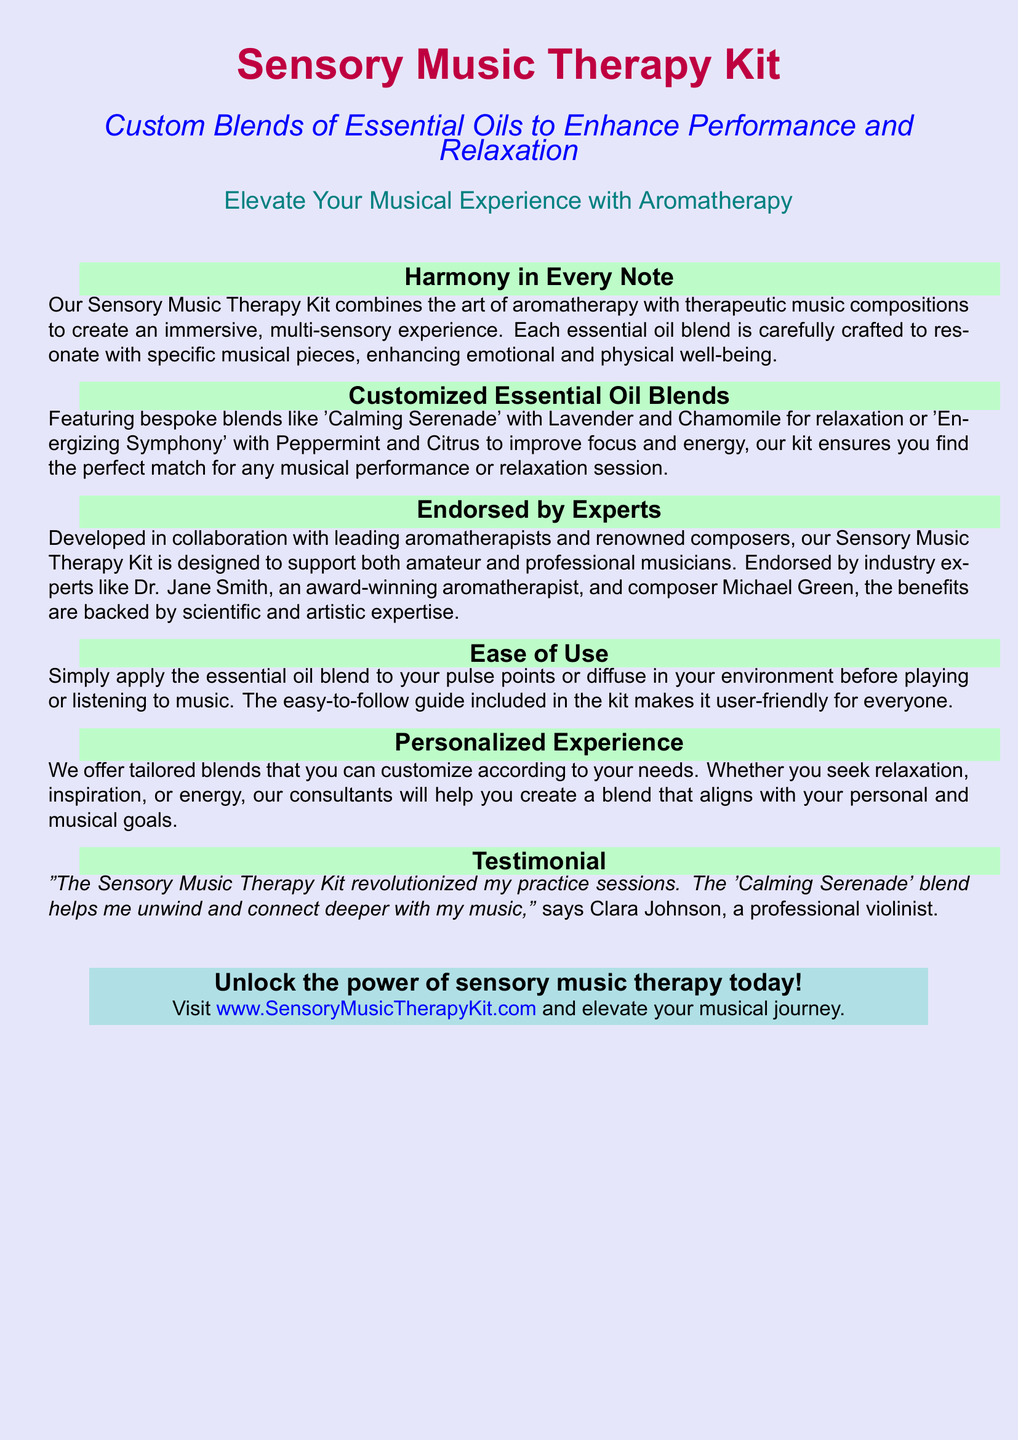What is the name of the product? The product is named in the document as the "Sensory Music Therapy Kit."
Answer: Sensory Music Therapy Kit What are the two essential oils in the 'Calming Serenade' blend? The document specifies that 'Calming Serenade' contains Lavender and Chamomile.
Answer: Lavender and Chamomile Who endorsed the Sensory Music Therapy Kit? The document mentions endorsements from experts like Dr. Jane Smith and composer Michael Green.
Answer: Dr. Jane Smith and Michael Green What is the purpose of the 'Energizing Symphony' blend? The 'Energizing Symphony' blend is designed to improve focus and energy.
Answer: Improve focus and energy How can users apply the essential oil blends? Users can apply the blends to their pulse points or diffuse them in their environment, as per the document.
Answer: Pulse points or diffuse What should users visit to unlock the power of sensory music therapy? The document prompts users to visit a specific website to access the Sensory Music Therapy Kit.
Answer: www.SensoryMusicTherapyKit.com Who is Clara Johnson? Clara Johnson is identified in the document as a professional violinist providing a testimonial for the product.
Answer: Professional violinist What type of experience does the Sensory Music Therapy Kit aim to enhance? The kit aims to enhance musical experience through the combination of aromatherapy and music.
Answer: Musical experience 